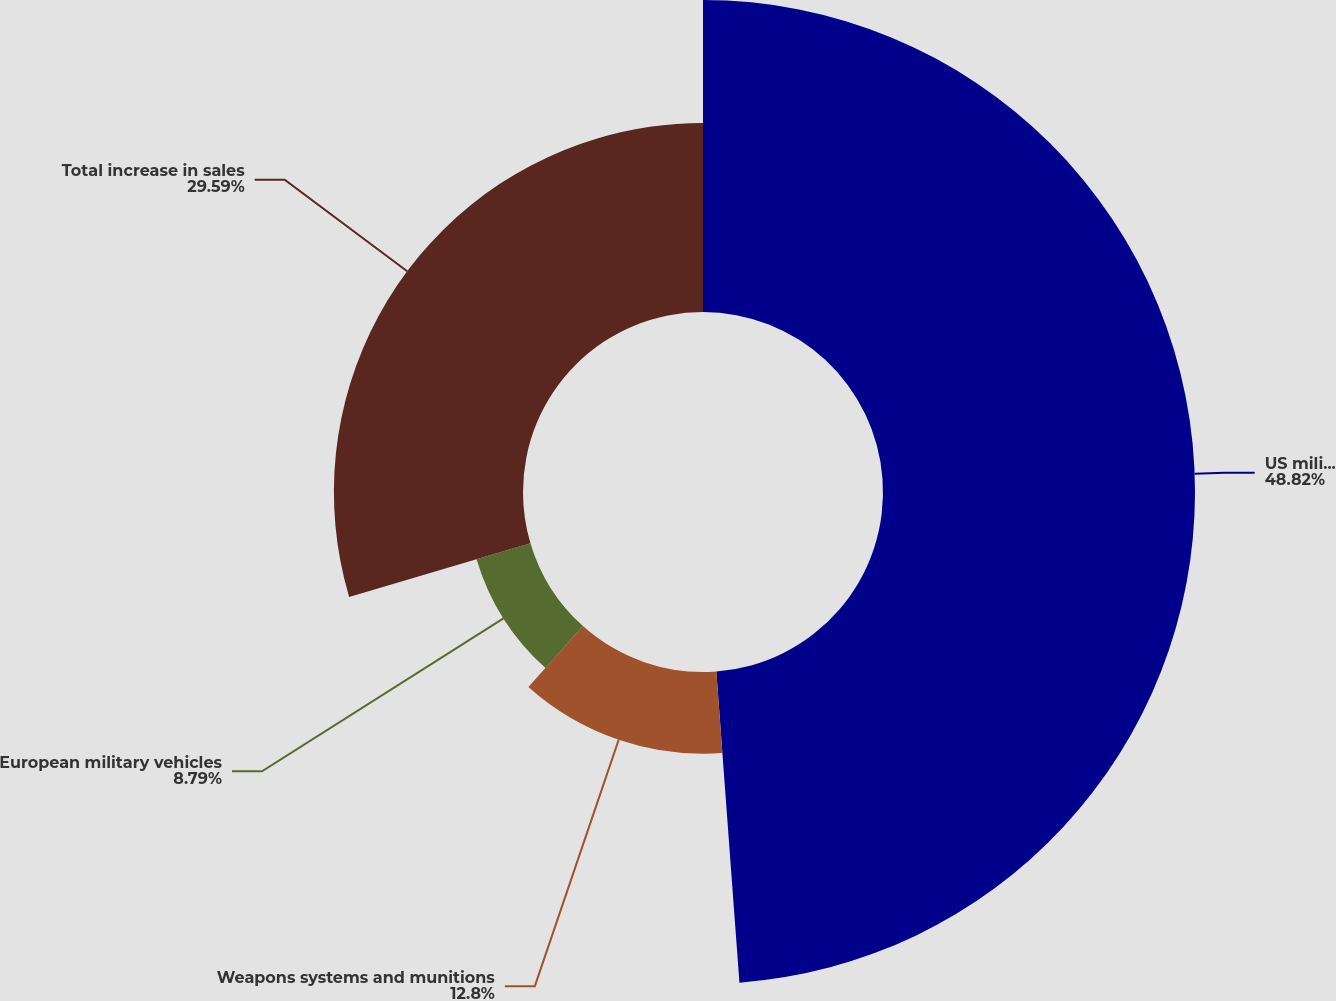<chart> <loc_0><loc_0><loc_500><loc_500><pie_chart><fcel>US military vehicles<fcel>Weapons systems and munitions<fcel>European military vehicles<fcel>Total increase in sales<nl><fcel>48.82%<fcel>12.8%<fcel>8.79%<fcel>29.59%<nl></chart> 